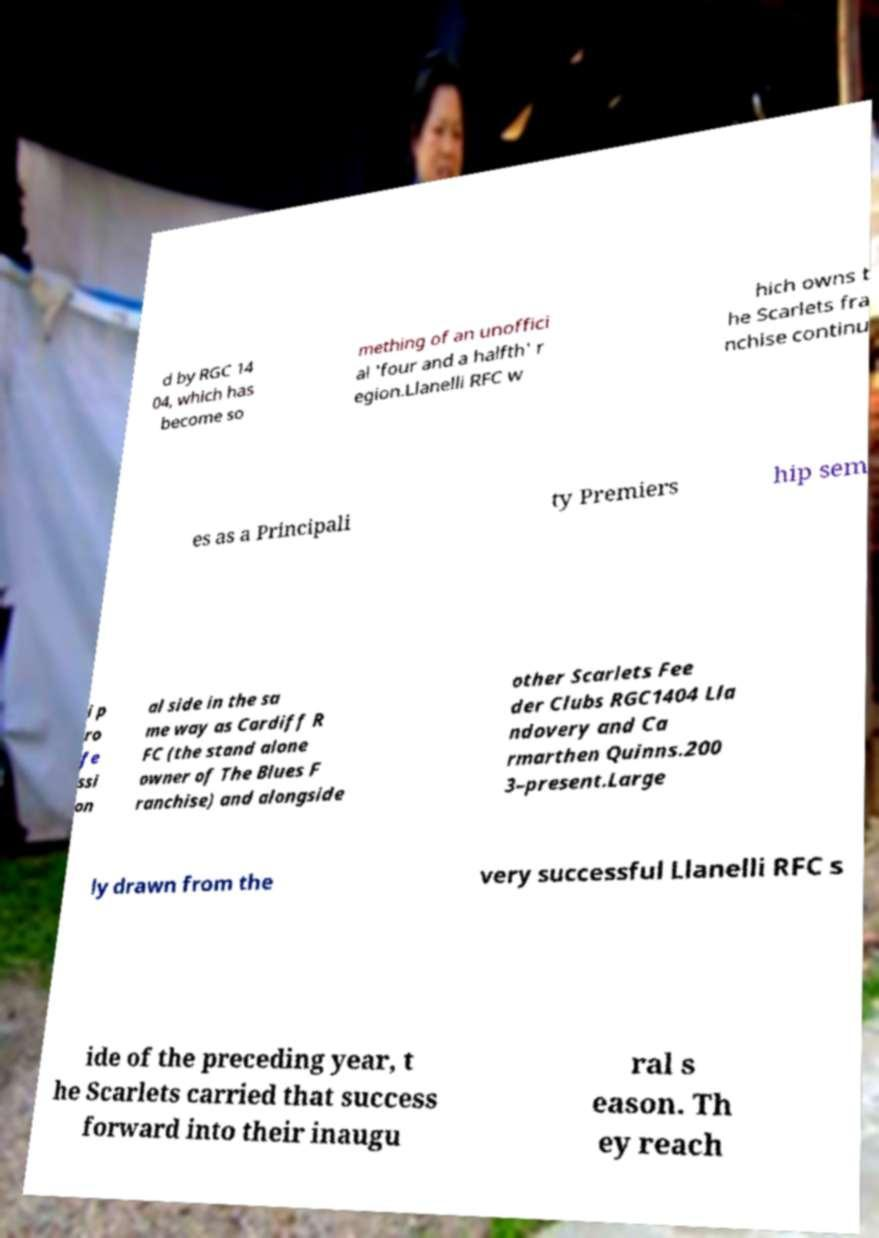Could you extract and type out the text from this image? d by RGC 14 04, which has become so mething of an unoffici al 'four and a halfth' r egion.Llanelli RFC w hich owns t he Scarlets fra nchise continu es as a Principali ty Premiers hip sem i p ro fe ssi on al side in the sa me way as Cardiff R FC (the stand alone owner of The Blues F ranchise) and alongside other Scarlets Fee der Clubs RGC1404 Lla ndovery and Ca rmarthen Quinns.200 3–present.Large ly drawn from the very successful Llanelli RFC s ide of the preceding year, t he Scarlets carried that success forward into their inaugu ral s eason. Th ey reach 